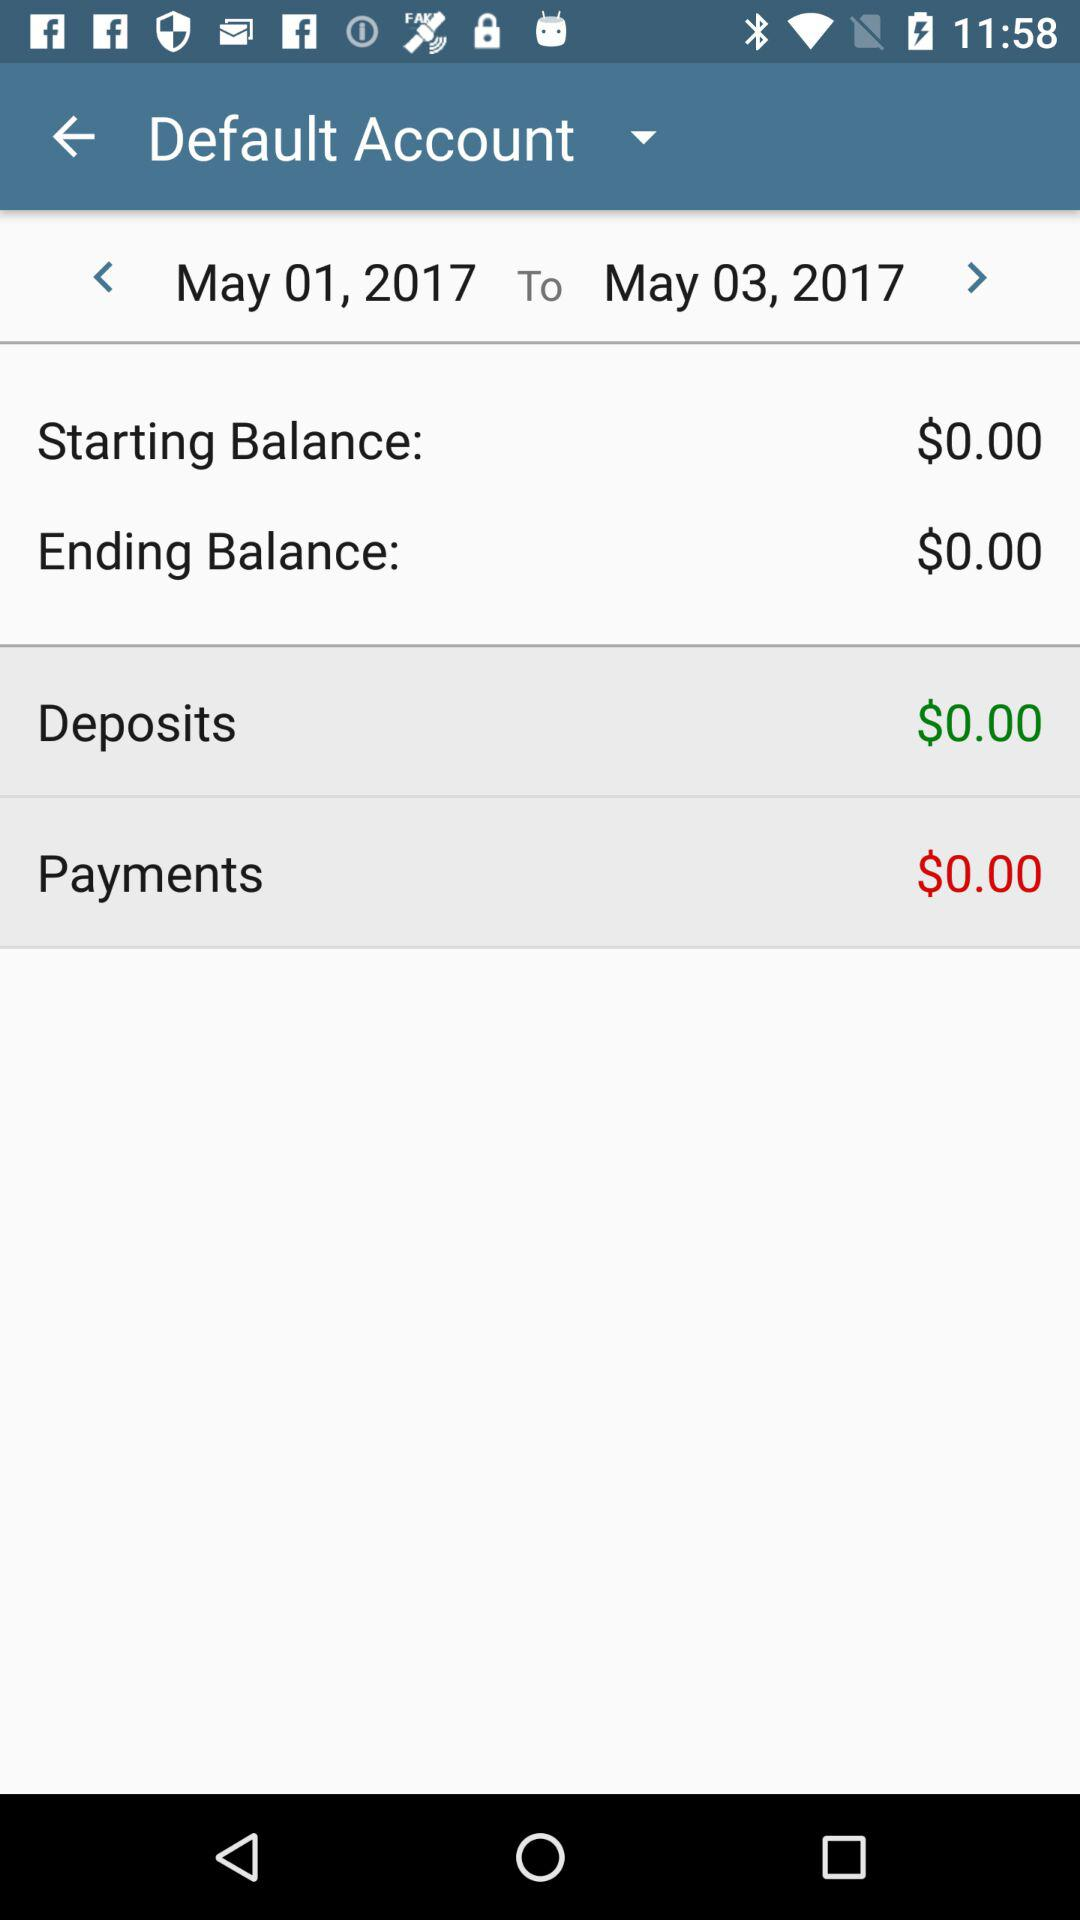How much is the deposit? The deposit is $0.00. 